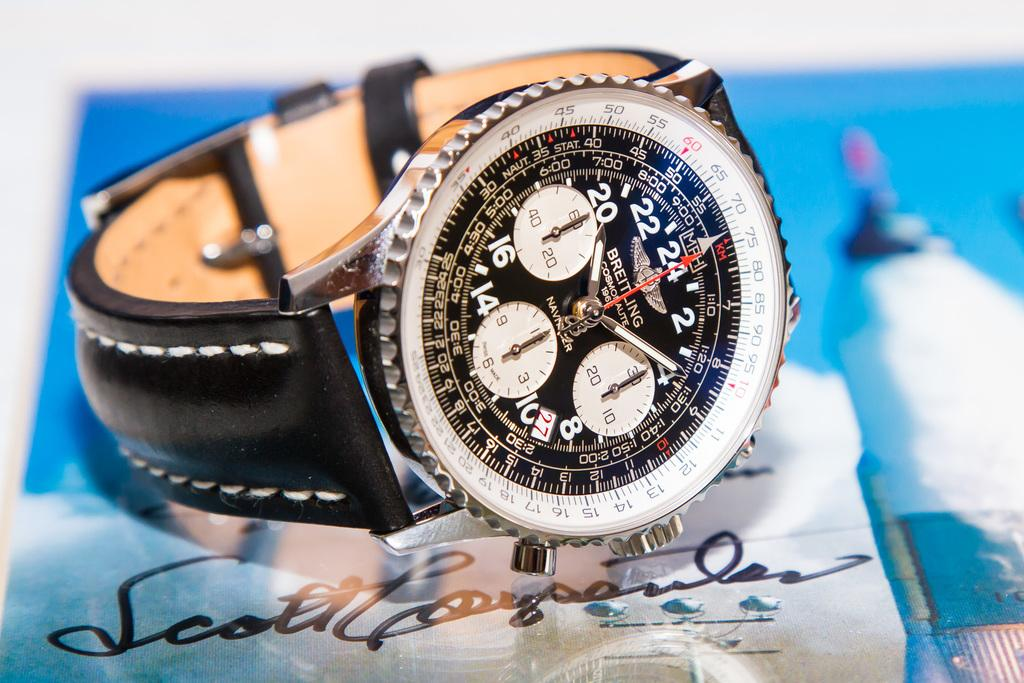<image>
Create a compact narrative representing the image presented. The watch on the table has several different dials on it and underneath, on the table, something is signed by Scott. 